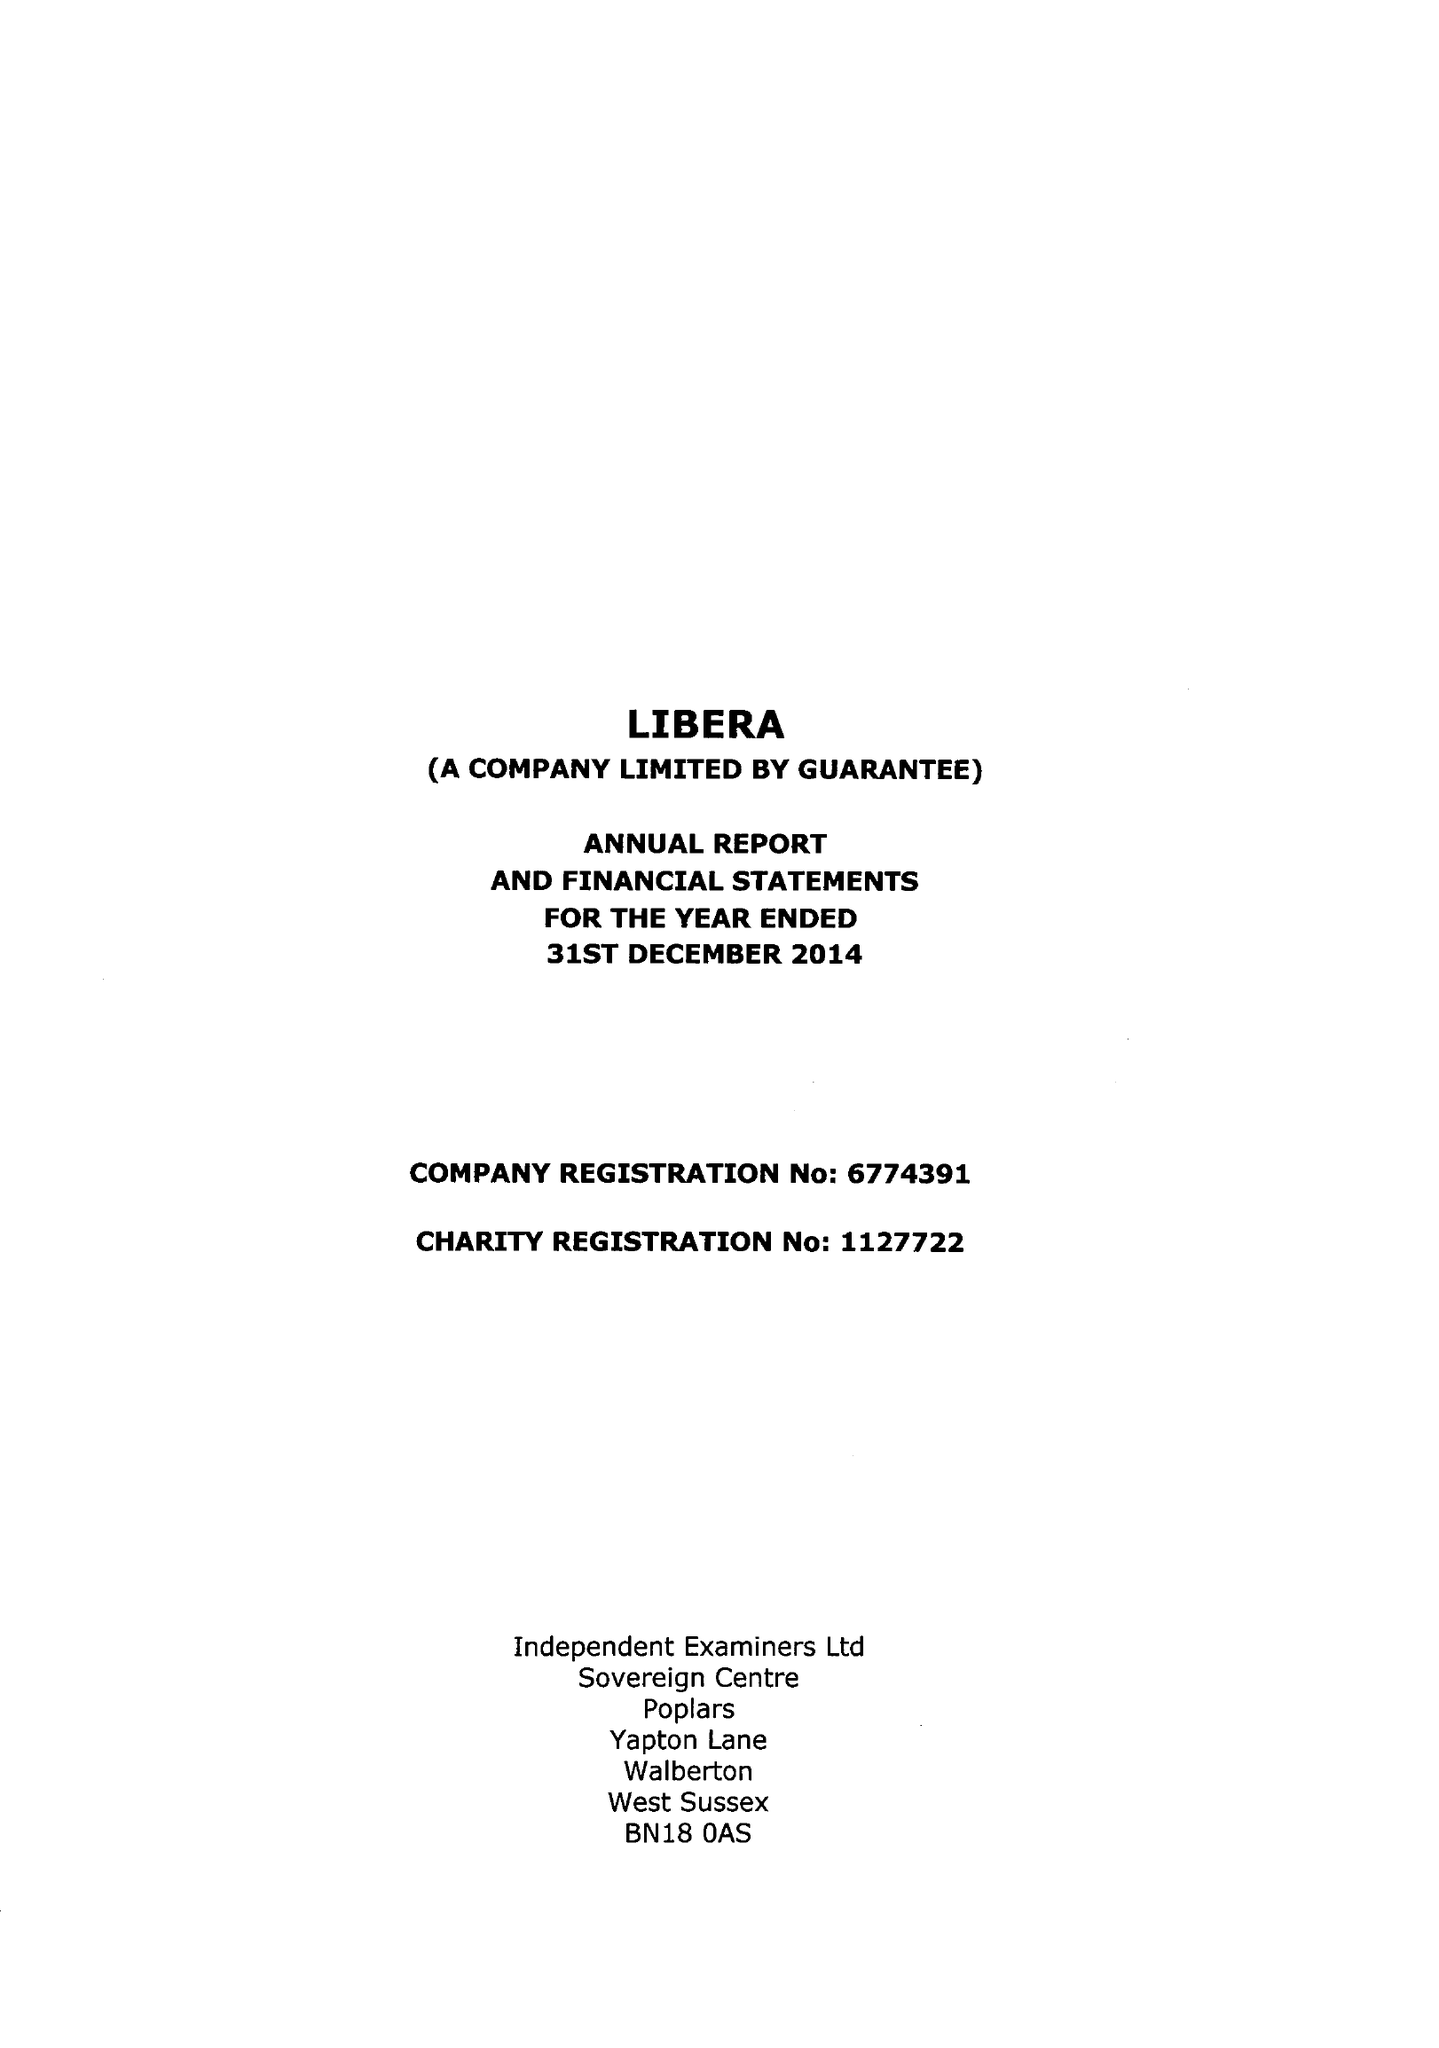What is the value for the income_annually_in_british_pounds?
Answer the question using a single word or phrase. 53173.00 